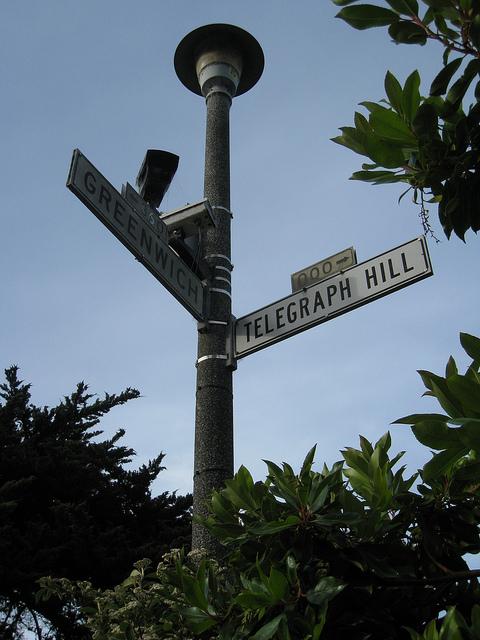Is this post and light old-fashioned looking?
Keep it brief. Yes. What is the name of the street?
Give a very brief answer. Telegraph hill. What is the main subject of this picture used for?
Answer briefly. Directions. Do the signs refer to different streets?
Give a very brief answer. Yes. What time of day is it?
Short answer required. Morning. Is there more than one sign on the post?
Keep it brief. Yes. What is the name of the road?
Answer briefly. Telegraph hill. What is the statue holding?
Keep it brief. Signs. What is this used for?
Concise answer only. Direction. Is there a light on the post?
Short answer required. Yes. 